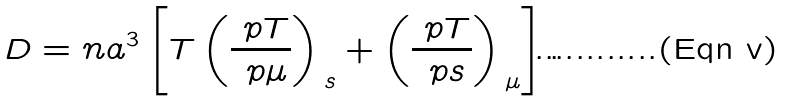Convert formula to latex. <formula><loc_0><loc_0><loc_500><loc_500>D & = n a ^ { 3 } \left [ T \left ( \frac { \ p T } { \ p \mu } \right ) _ { \, s } + \left ( \frac { \ p T } { \ p s } \right ) _ { \, \mu } \right ] .</formula> 